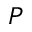Convert formula to latex. <formula><loc_0><loc_0><loc_500><loc_500>P</formula> 